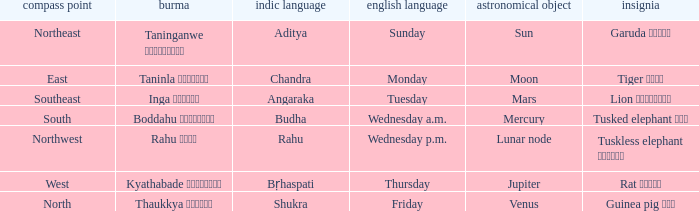What is the cardinal direction associated with Venus? North. 